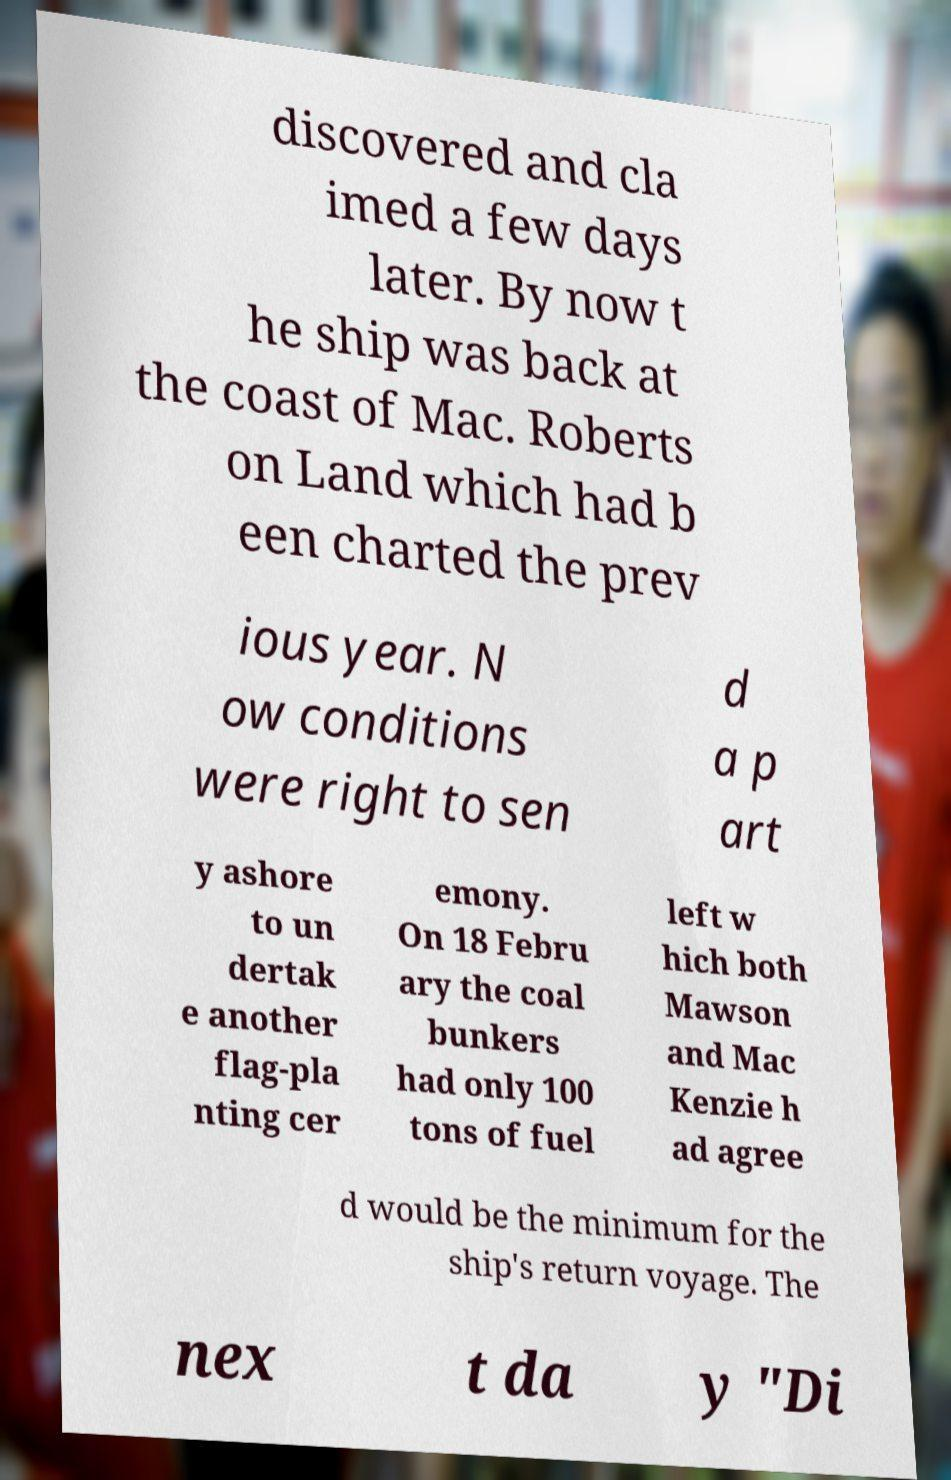Can you read and provide the text displayed in the image?This photo seems to have some interesting text. Can you extract and type it out for me? discovered and cla imed a few days later. By now t he ship was back at the coast of Mac. Roberts on Land which had b een charted the prev ious year. N ow conditions were right to sen d a p art y ashore to un dertak e another flag-pla nting cer emony. On 18 Febru ary the coal bunkers had only 100 tons of fuel left w hich both Mawson and Mac Kenzie h ad agree d would be the minimum for the ship's return voyage. The nex t da y "Di 